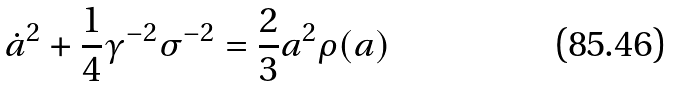Convert formula to latex. <formula><loc_0><loc_0><loc_500><loc_500>\dot { a } ^ { 2 } + \frac { 1 } { 4 } \gamma ^ { - 2 } \sigma ^ { - 2 } = \frac { 2 } { 3 } a ^ { 2 } \rho ( a )</formula> 